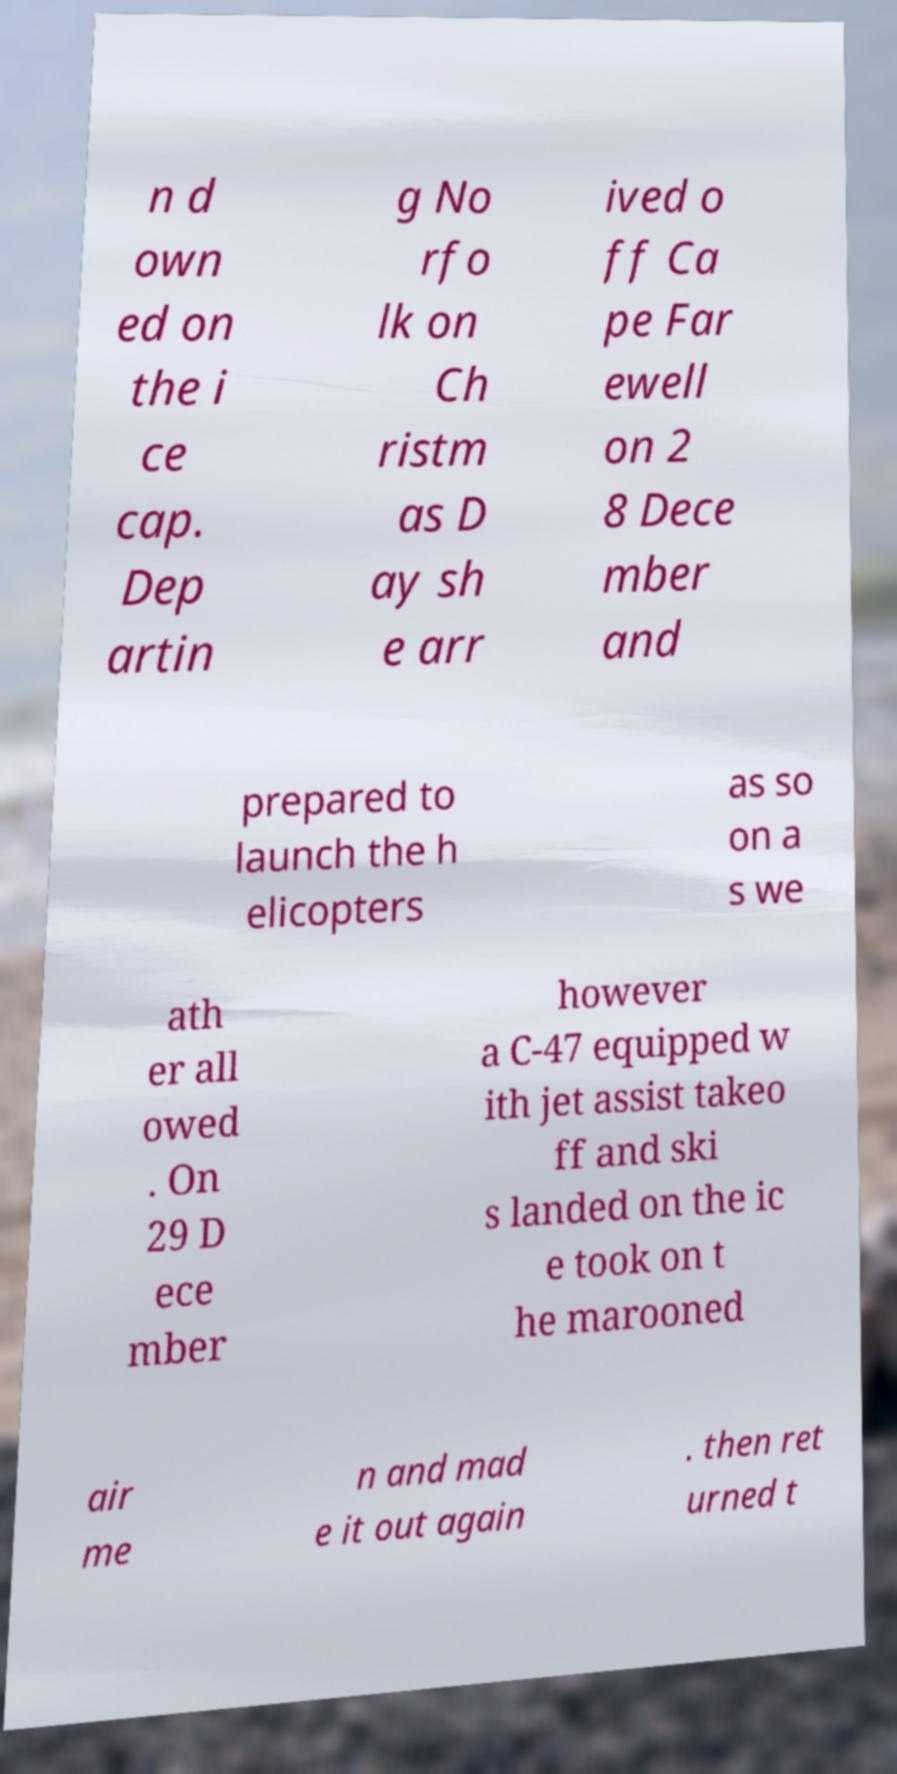Please read and relay the text visible in this image. What does it say? n d own ed on the i ce cap. Dep artin g No rfo lk on Ch ristm as D ay sh e arr ived o ff Ca pe Far ewell on 2 8 Dece mber and prepared to launch the h elicopters as so on a s we ath er all owed . On 29 D ece mber however a C-47 equipped w ith jet assist takeo ff and ski s landed on the ic e took on t he marooned air me n and mad e it out again . then ret urned t 